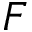Convert formula to latex. <formula><loc_0><loc_0><loc_500><loc_500>F</formula> 